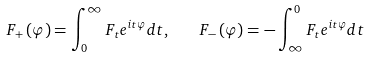Convert formula to latex. <formula><loc_0><loc_0><loc_500><loc_500>F _ { + } \left ( \varphi \right ) = \int _ { 0 } ^ { \infty } F _ { t } e ^ { i t \varphi } d t , \quad F _ { - } \left ( \varphi \right ) = - \int _ { \infty } ^ { 0 } F _ { t } e ^ { i t \varphi } d t</formula> 